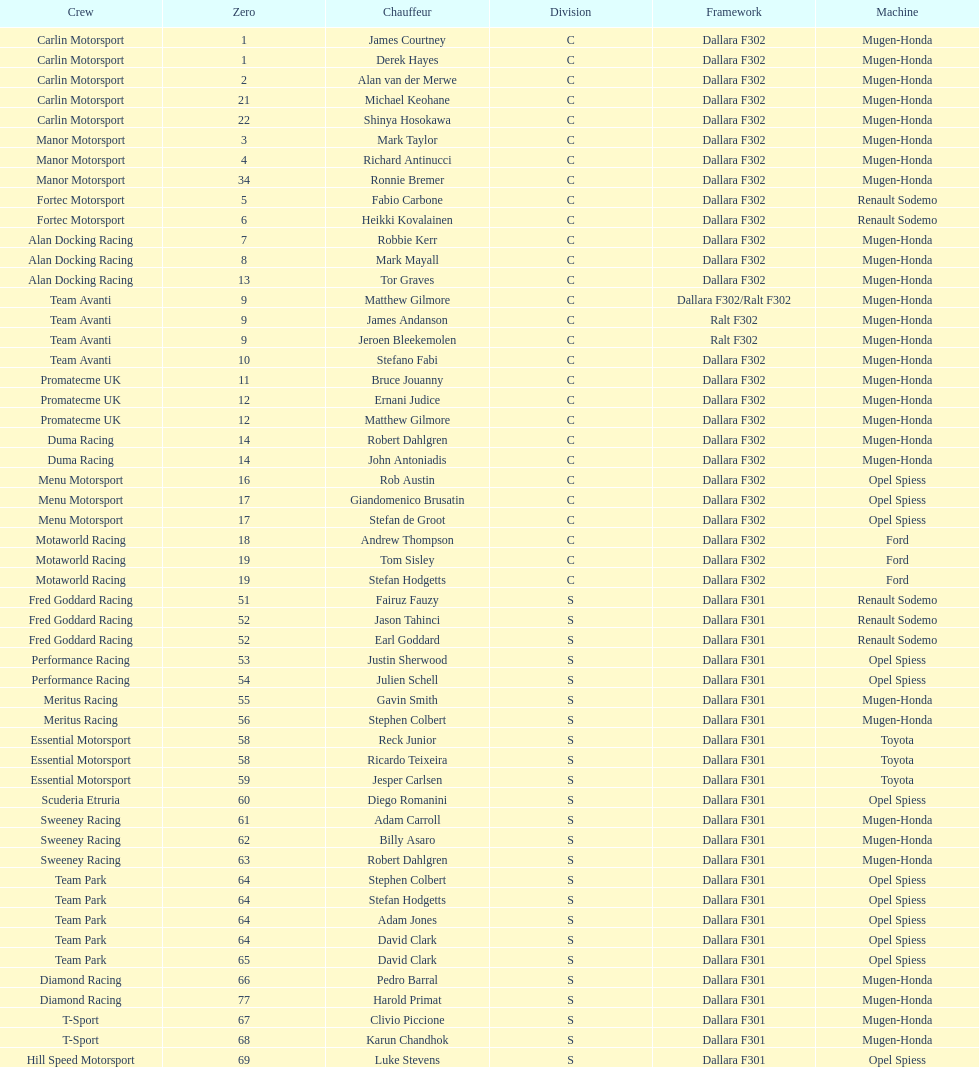How many teams had at least two drivers this season? 17. 